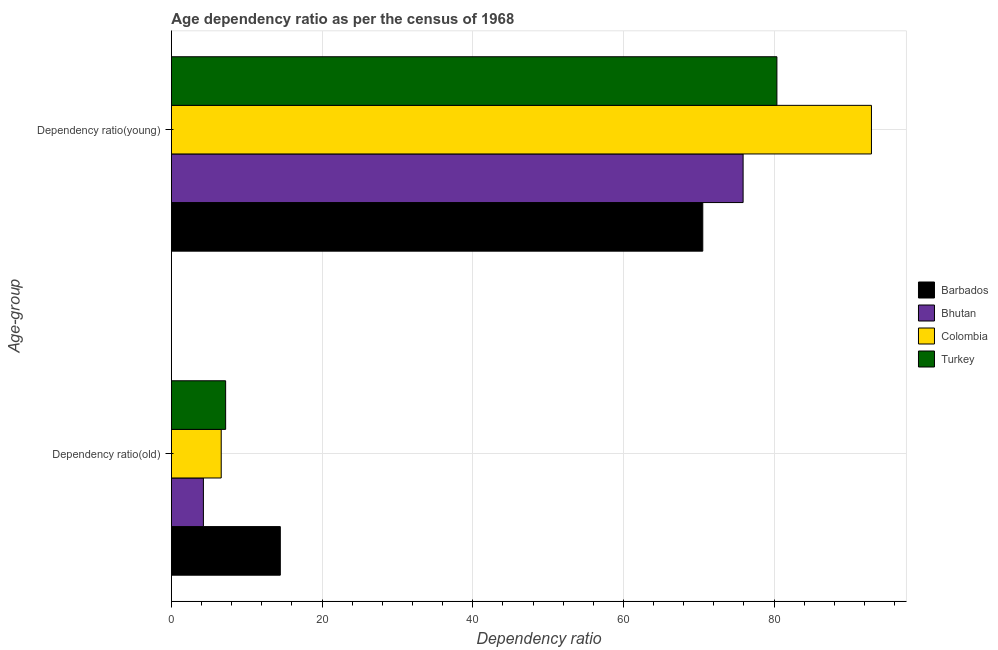What is the label of the 1st group of bars from the top?
Ensure brevity in your answer.  Dependency ratio(young). What is the age dependency ratio(old) in Barbados?
Offer a terse response. 14.46. Across all countries, what is the maximum age dependency ratio(young)?
Provide a succinct answer. 92.92. Across all countries, what is the minimum age dependency ratio(old)?
Your answer should be compact. 4.25. In which country was the age dependency ratio(old) maximum?
Ensure brevity in your answer.  Barbados. In which country was the age dependency ratio(young) minimum?
Provide a succinct answer. Barbados. What is the total age dependency ratio(young) in the graph?
Keep it short and to the point. 319.72. What is the difference between the age dependency ratio(old) in Bhutan and that in Barbados?
Keep it short and to the point. -10.21. What is the difference between the age dependency ratio(young) in Bhutan and the age dependency ratio(old) in Turkey?
Offer a terse response. 68.69. What is the average age dependency ratio(young) per country?
Your answer should be compact. 79.93. What is the difference between the age dependency ratio(young) and age dependency ratio(old) in Barbados?
Offer a very short reply. 56.07. In how many countries, is the age dependency ratio(old) greater than 36 ?
Provide a short and direct response. 0. What is the ratio of the age dependency ratio(old) in Turkey to that in Bhutan?
Offer a very short reply. 1.69. In how many countries, is the age dependency ratio(old) greater than the average age dependency ratio(old) taken over all countries?
Provide a succinct answer. 1. What does the 4th bar from the top in Dependency ratio(old) represents?
Your response must be concise. Barbados. How many countries are there in the graph?
Your answer should be compact. 4. What is the difference between two consecutive major ticks on the X-axis?
Make the answer very short. 20. Are the values on the major ticks of X-axis written in scientific E-notation?
Ensure brevity in your answer.  No. Does the graph contain any zero values?
Provide a succinct answer. No. How many legend labels are there?
Provide a succinct answer. 4. How are the legend labels stacked?
Your response must be concise. Vertical. What is the title of the graph?
Your answer should be very brief. Age dependency ratio as per the census of 1968. Does "OECD members" appear as one of the legend labels in the graph?
Give a very brief answer. No. What is the label or title of the X-axis?
Keep it short and to the point. Dependency ratio. What is the label or title of the Y-axis?
Give a very brief answer. Age-group. What is the Dependency ratio of Barbados in Dependency ratio(old)?
Provide a succinct answer. 14.46. What is the Dependency ratio in Bhutan in Dependency ratio(old)?
Offer a terse response. 4.25. What is the Dependency ratio of Colombia in Dependency ratio(old)?
Your response must be concise. 6.62. What is the Dependency ratio in Turkey in Dependency ratio(old)?
Provide a short and direct response. 7.2. What is the Dependency ratio of Barbados in Dependency ratio(young)?
Your response must be concise. 70.53. What is the Dependency ratio of Bhutan in Dependency ratio(young)?
Offer a terse response. 75.89. What is the Dependency ratio of Colombia in Dependency ratio(young)?
Provide a succinct answer. 92.92. What is the Dependency ratio of Turkey in Dependency ratio(young)?
Provide a succinct answer. 80.37. Across all Age-group, what is the maximum Dependency ratio of Barbados?
Offer a very short reply. 70.53. Across all Age-group, what is the maximum Dependency ratio of Bhutan?
Ensure brevity in your answer.  75.89. Across all Age-group, what is the maximum Dependency ratio in Colombia?
Offer a terse response. 92.92. Across all Age-group, what is the maximum Dependency ratio of Turkey?
Provide a succinct answer. 80.37. Across all Age-group, what is the minimum Dependency ratio of Barbados?
Provide a short and direct response. 14.46. Across all Age-group, what is the minimum Dependency ratio of Bhutan?
Ensure brevity in your answer.  4.25. Across all Age-group, what is the minimum Dependency ratio of Colombia?
Your answer should be compact. 6.62. Across all Age-group, what is the minimum Dependency ratio in Turkey?
Give a very brief answer. 7.2. What is the total Dependency ratio of Barbados in the graph?
Your response must be concise. 84.99. What is the total Dependency ratio in Bhutan in the graph?
Provide a succinct answer. 80.14. What is the total Dependency ratio in Colombia in the graph?
Offer a very short reply. 99.54. What is the total Dependency ratio of Turkey in the graph?
Your answer should be very brief. 87.58. What is the difference between the Dependency ratio in Barbados in Dependency ratio(old) and that in Dependency ratio(young)?
Your answer should be compact. -56.07. What is the difference between the Dependency ratio of Bhutan in Dependency ratio(old) and that in Dependency ratio(young)?
Provide a succinct answer. -71.64. What is the difference between the Dependency ratio in Colombia in Dependency ratio(old) and that in Dependency ratio(young)?
Provide a short and direct response. -86.31. What is the difference between the Dependency ratio in Turkey in Dependency ratio(old) and that in Dependency ratio(young)?
Offer a very short reply. -73.17. What is the difference between the Dependency ratio of Barbados in Dependency ratio(old) and the Dependency ratio of Bhutan in Dependency ratio(young)?
Keep it short and to the point. -61.43. What is the difference between the Dependency ratio of Barbados in Dependency ratio(old) and the Dependency ratio of Colombia in Dependency ratio(young)?
Your answer should be compact. -78.46. What is the difference between the Dependency ratio of Barbados in Dependency ratio(old) and the Dependency ratio of Turkey in Dependency ratio(young)?
Offer a very short reply. -65.91. What is the difference between the Dependency ratio in Bhutan in Dependency ratio(old) and the Dependency ratio in Colombia in Dependency ratio(young)?
Provide a succinct answer. -88.67. What is the difference between the Dependency ratio of Bhutan in Dependency ratio(old) and the Dependency ratio of Turkey in Dependency ratio(young)?
Offer a very short reply. -76.12. What is the difference between the Dependency ratio of Colombia in Dependency ratio(old) and the Dependency ratio of Turkey in Dependency ratio(young)?
Make the answer very short. -73.76. What is the average Dependency ratio in Barbados per Age-group?
Your answer should be very brief. 42.5. What is the average Dependency ratio of Bhutan per Age-group?
Your response must be concise. 40.07. What is the average Dependency ratio of Colombia per Age-group?
Your answer should be very brief. 49.77. What is the average Dependency ratio of Turkey per Age-group?
Keep it short and to the point. 43.79. What is the difference between the Dependency ratio of Barbados and Dependency ratio of Bhutan in Dependency ratio(old)?
Keep it short and to the point. 10.21. What is the difference between the Dependency ratio in Barbados and Dependency ratio in Colombia in Dependency ratio(old)?
Make the answer very short. 7.84. What is the difference between the Dependency ratio of Barbados and Dependency ratio of Turkey in Dependency ratio(old)?
Your answer should be very brief. 7.26. What is the difference between the Dependency ratio in Bhutan and Dependency ratio in Colombia in Dependency ratio(old)?
Give a very brief answer. -2.36. What is the difference between the Dependency ratio of Bhutan and Dependency ratio of Turkey in Dependency ratio(old)?
Make the answer very short. -2.95. What is the difference between the Dependency ratio of Colombia and Dependency ratio of Turkey in Dependency ratio(old)?
Keep it short and to the point. -0.59. What is the difference between the Dependency ratio of Barbados and Dependency ratio of Bhutan in Dependency ratio(young)?
Make the answer very short. -5.35. What is the difference between the Dependency ratio in Barbados and Dependency ratio in Colombia in Dependency ratio(young)?
Offer a terse response. -22.39. What is the difference between the Dependency ratio in Barbados and Dependency ratio in Turkey in Dependency ratio(young)?
Provide a short and direct response. -9.84. What is the difference between the Dependency ratio in Bhutan and Dependency ratio in Colombia in Dependency ratio(young)?
Ensure brevity in your answer.  -17.04. What is the difference between the Dependency ratio in Bhutan and Dependency ratio in Turkey in Dependency ratio(young)?
Offer a terse response. -4.49. What is the difference between the Dependency ratio in Colombia and Dependency ratio in Turkey in Dependency ratio(young)?
Make the answer very short. 12.55. What is the ratio of the Dependency ratio in Barbados in Dependency ratio(old) to that in Dependency ratio(young)?
Make the answer very short. 0.2. What is the ratio of the Dependency ratio in Bhutan in Dependency ratio(old) to that in Dependency ratio(young)?
Your answer should be compact. 0.06. What is the ratio of the Dependency ratio in Colombia in Dependency ratio(old) to that in Dependency ratio(young)?
Your answer should be very brief. 0.07. What is the ratio of the Dependency ratio in Turkey in Dependency ratio(old) to that in Dependency ratio(young)?
Ensure brevity in your answer.  0.09. What is the difference between the highest and the second highest Dependency ratio of Barbados?
Your response must be concise. 56.07. What is the difference between the highest and the second highest Dependency ratio in Bhutan?
Your answer should be compact. 71.64. What is the difference between the highest and the second highest Dependency ratio in Colombia?
Give a very brief answer. 86.31. What is the difference between the highest and the second highest Dependency ratio in Turkey?
Your answer should be compact. 73.17. What is the difference between the highest and the lowest Dependency ratio in Barbados?
Your response must be concise. 56.07. What is the difference between the highest and the lowest Dependency ratio of Bhutan?
Keep it short and to the point. 71.64. What is the difference between the highest and the lowest Dependency ratio in Colombia?
Offer a terse response. 86.31. What is the difference between the highest and the lowest Dependency ratio in Turkey?
Make the answer very short. 73.17. 